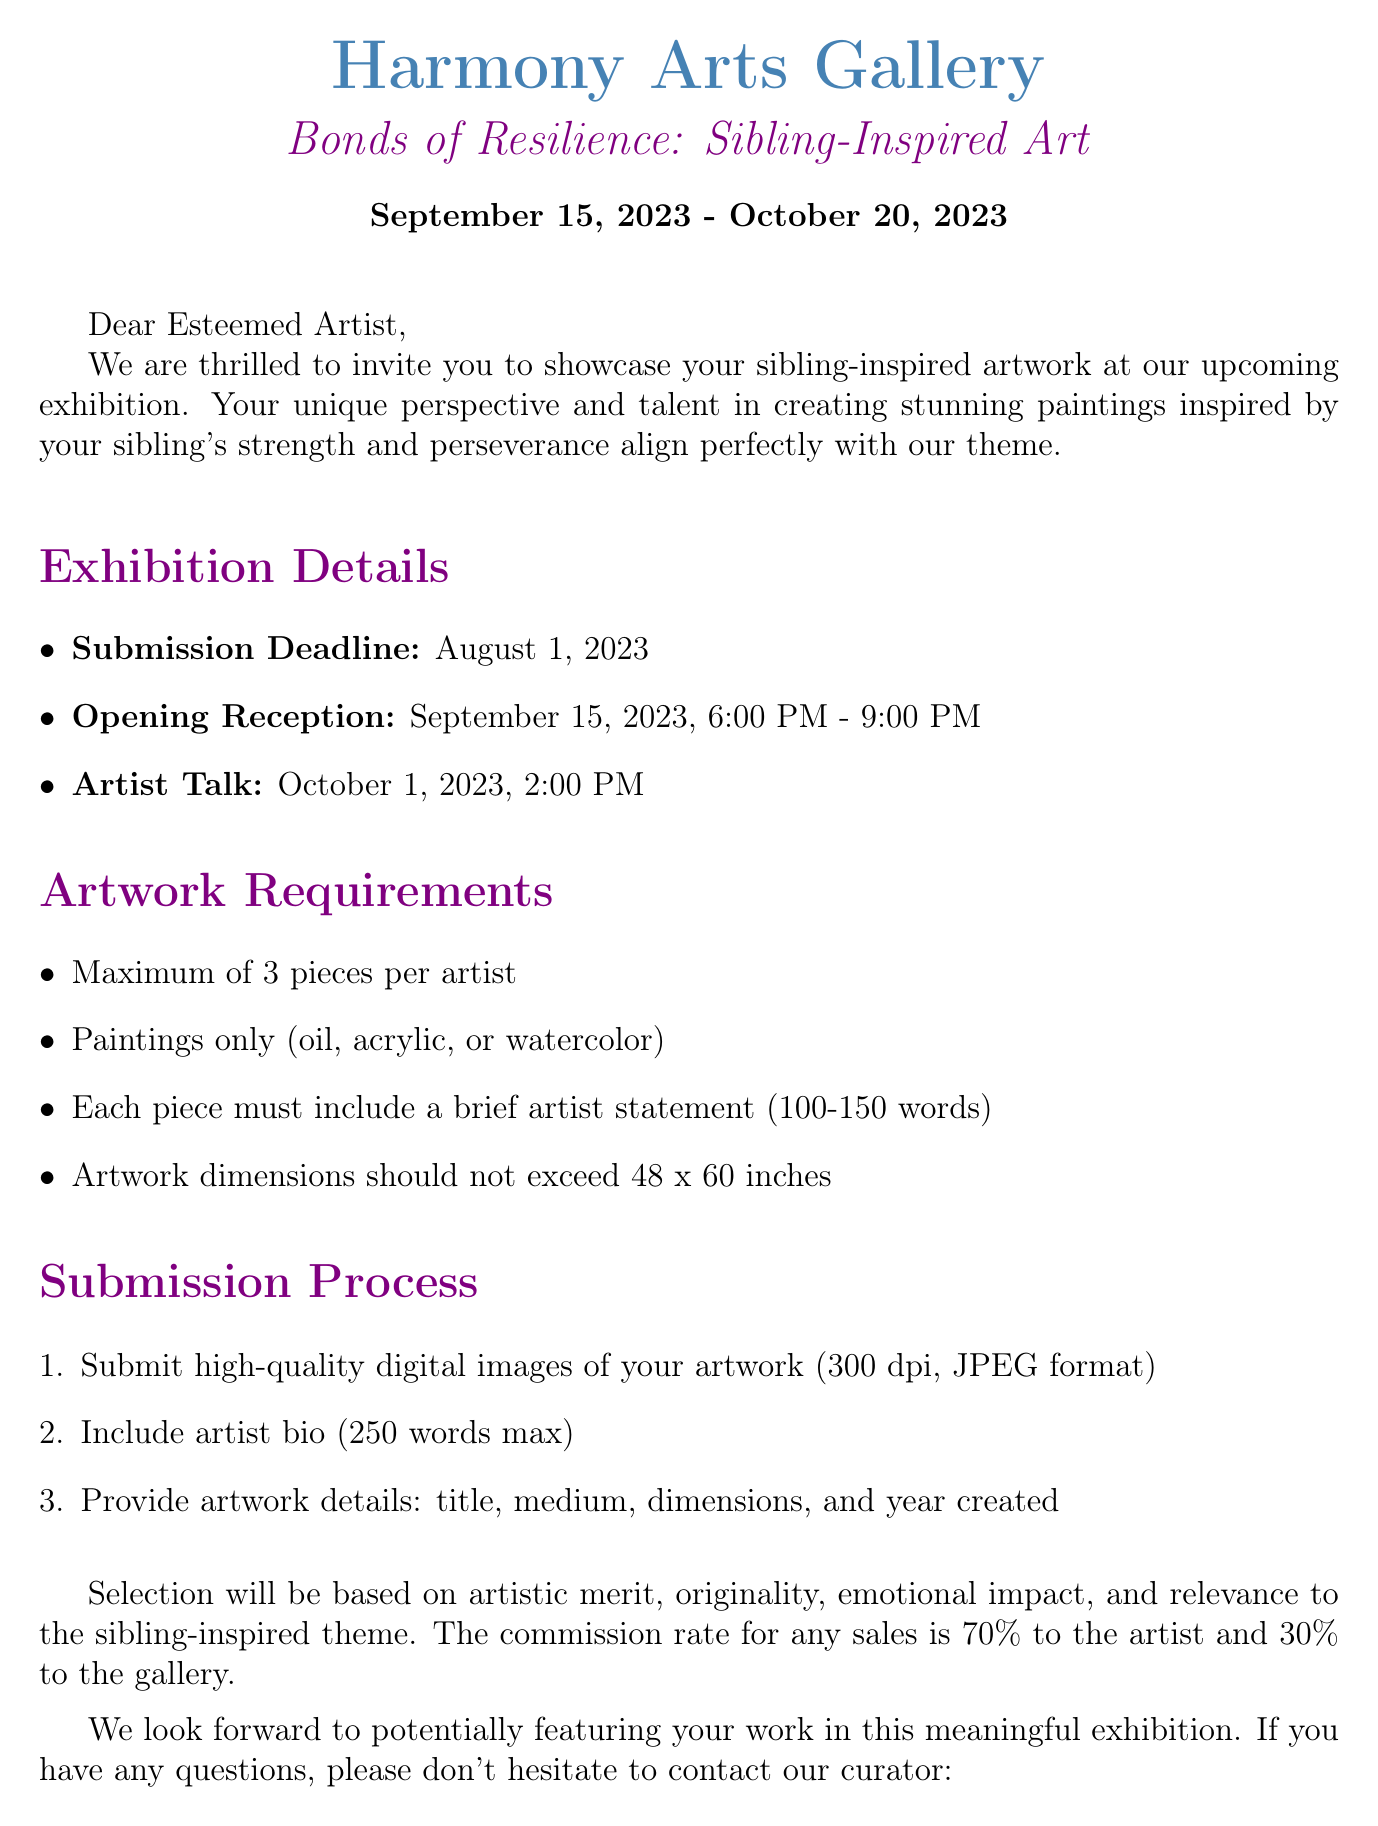what is the name of the gallery? The gallery is referred to as Harmony Arts Gallery in the document.
Answer: Harmony Arts Gallery what is the title of the exhibition? The title of the exhibition is given in the document as "Bonds of Resilience: Sibling-Inspired Art".
Answer: Bonds of Resilience: Sibling-Inspired Art what are the exhibition dates? The document specifies the start and end dates of the exhibition.
Answer: September 15, 2023 - October 20, 2023 what is the submission deadline for artworks? The document mentions a specific deadline by which submissions must be made.
Answer: August 1, 2023 how many pieces of artwork can each artist submit? The document states the maximum number of pieces an artist can submit.
Answer: Maximum of 3 pieces who is the contact person for inquiries? The document identifies the curator as the contact person for questions regarding the submission.
Answer: Emily Chen what is the commission rate for any sales from the exhibition? The document outlines the division of sales earnings between the artist and the gallery.
Answer: 70% to the artist, 30% to the gallery what mediums are accepted for the artwork? The document specifies the types of paintings that are eligible for submission.
Answer: Oil, acrylic, or watercolor what is the maximum dimension for the artwork? The document provides the maximum size limitation for artwork submissions.
Answer: 48 x 60 inches 